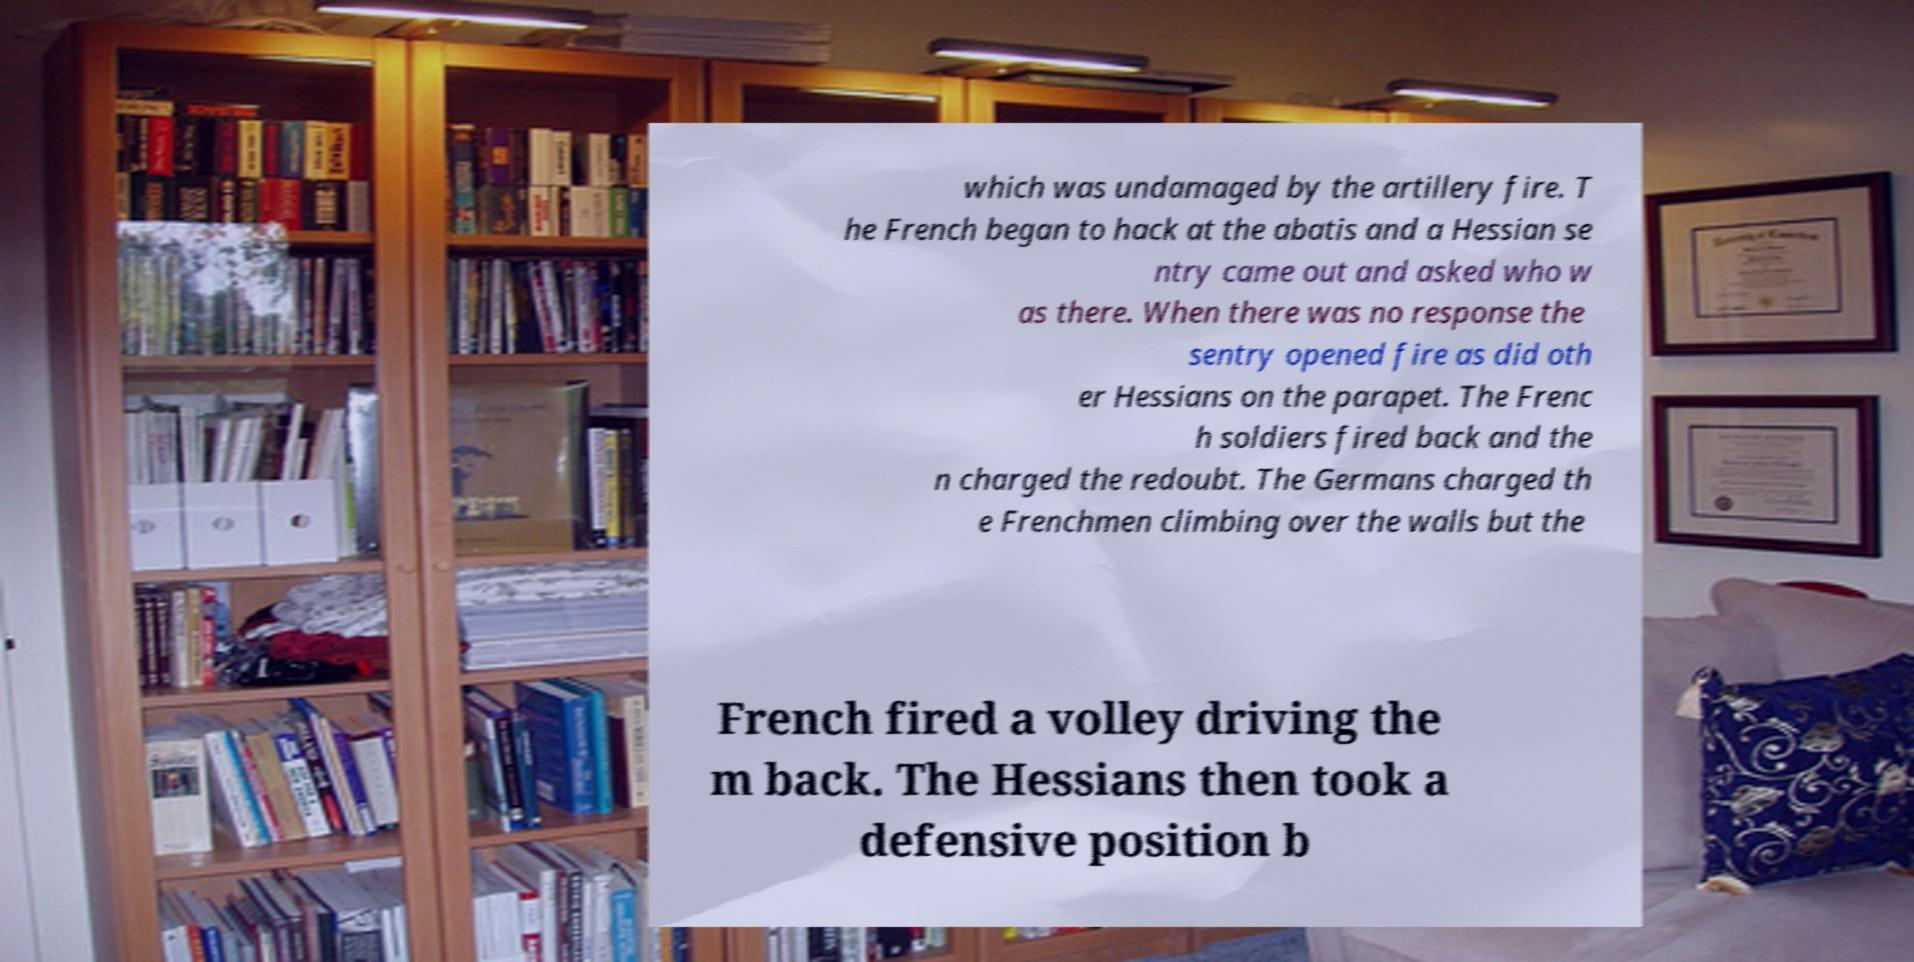Could you assist in decoding the text presented in this image and type it out clearly? which was undamaged by the artillery fire. T he French began to hack at the abatis and a Hessian se ntry came out and asked who w as there. When there was no response the sentry opened fire as did oth er Hessians on the parapet. The Frenc h soldiers fired back and the n charged the redoubt. The Germans charged th e Frenchmen climbing over the walls but the French fired a volley driving the m back. The Hessians then took a defensive position b 